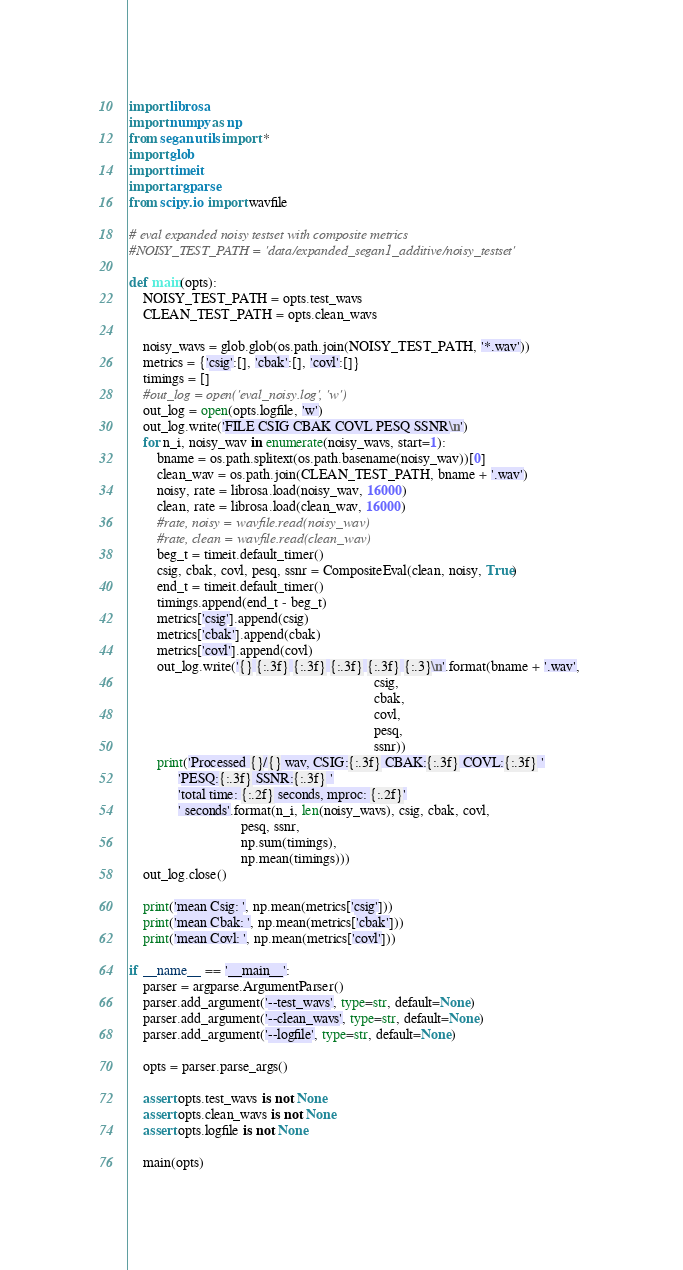<code> <loc_0><loc_0><loc_500><loc_500><_Python_>import librosa
import numpy as np
from segan.utils import *
import glob
import timeit
import argparse
from scipy.io import wavfile

# eval expanded noisy testset with composite metrics
#NOISY_TEST_PATH = 'data/expanded_segan1_additive/noisy_testset'

def main(opts):
    NOISY_TEST_PATH = opts.test_wavs
    CLEAN_TEST_PATH = opts.clean_wavs

    noisy_wavs = glob.glob(os.path.join(NOISY_TEST_PATH, '*.wav'))
    metrics = {'csig':[], 'cbak':[], 'covl':[]}
    timings = []
    #out_log = open('eval_noisy.log', 'w')
    out_log = open(opts.logfile, 'w')
    out_log.write('FILE CSIG CBAK COVL PESQ SSNR\n')
    for n_i, noisy_wav in enumerate(noisy_wavs, start=1):
        bname = os.path.splitext(os.path.basename(noisy_wav))[0]
        clean_wav = os.path.join(CLEAN_TEST_PATH, bname + '.wav')
        noisy, rate = librosa.load(noisy_wav, 16000)
        clean, rate = librosa.load(clean_wav, 16000)
        #rate, noisy = wavfile.read(noisy_wav)
        #rate, clean = wavfile.read(clean_wav)
        beg_t = timeit.default_timer()
        csig, cbak, covl, pesq, ssnr = CompositeEval(clean, noisy, True)
        end_t = timeit.default_timer()
        timings.append(end_t - beg_t)
        metrics['csig'].append(csig)
        metrics['cbak'].append(cbak)
        metrics['covl'].append(covl)
        out_log.write('{} {:.3f} {:.3f} {:.3f} {:.3f} {:.3}\n'.format(bname + '.wav', 
                                                                      csig, 
                                                                      cbak, 
                                                                      covl,
                                                                      pesq,
                                                                      ssnr))
        print('Processed {}/{} wav, CSIG:{:.3f} CBAK:{:.3f} COVL:{:.3f} '
              'PESQ:{:.3f} SSNR:{:.3f} '
              'total time: {:.2f} seconds, mproc: {:.2f}'
              ' seconds'.format(n_i, len(noisy_wavs), csig, cbak, covl,
                                pesq, ssnr,
                                np.sum(timings),
                                np.mean(timings)))
    out_log.close()

    print('mean Csig: ', np.mean(metrics['csig']))
    print('mean Cbak: ', np.mean(metrics['cbak']))
    print('mean Covl: ', np.mean(metrics['covl']))

if __name__ == '__main__':
    parser = argparse.ArgumentParser()
    parser.add_argument('--test_wavs', type=str, default=None)
    parser.add_argument('--clean_wavs', type=str, default=None)
    parser.add_argument('--logfile', type=str, default=None)

    opts = parser.parse_args()

    assert opts.test_wavs is not None
    assert opts.clean_wavs is not None
    assert opts.logfile is not None

    main(opts)
</code> 